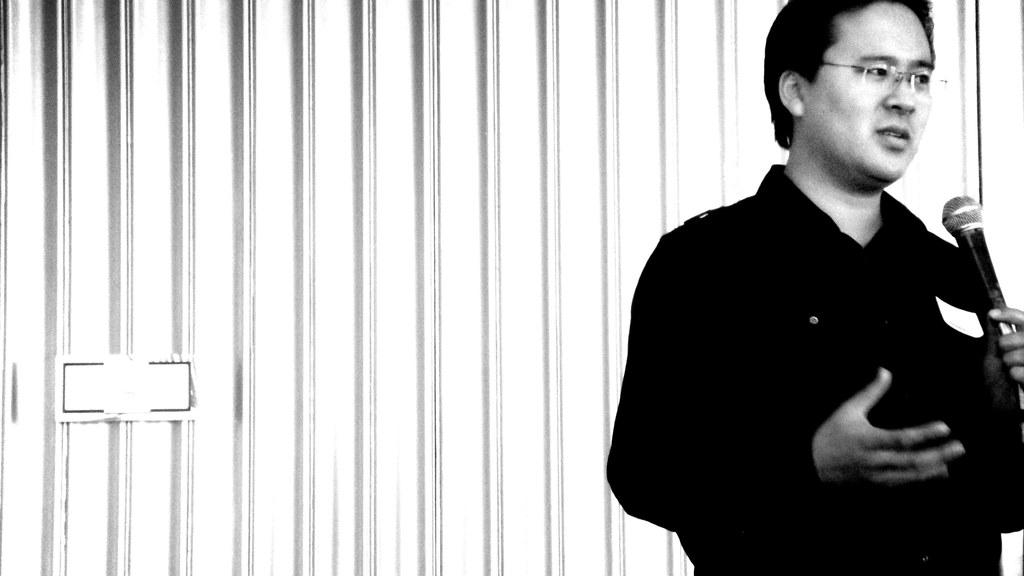What is the color scheme of the image? The image is black and white. Can you describe the person in the image? The person in the image is wearing spectacles. What is the person holding in the image? The person is holding a microphone. What can be seen in the background of the image? There is a wall in the image. Is there anything on the wall in the image? Yes, there is an object on the wall. Can you tell me how many fish are swimming in the image? There are no fish present in the image; it is a black and white image of a person holding a microphone with a wall and an object in the background. What type of tin is visible on the wall in the image? There is no tin visible on the wall in the image. 